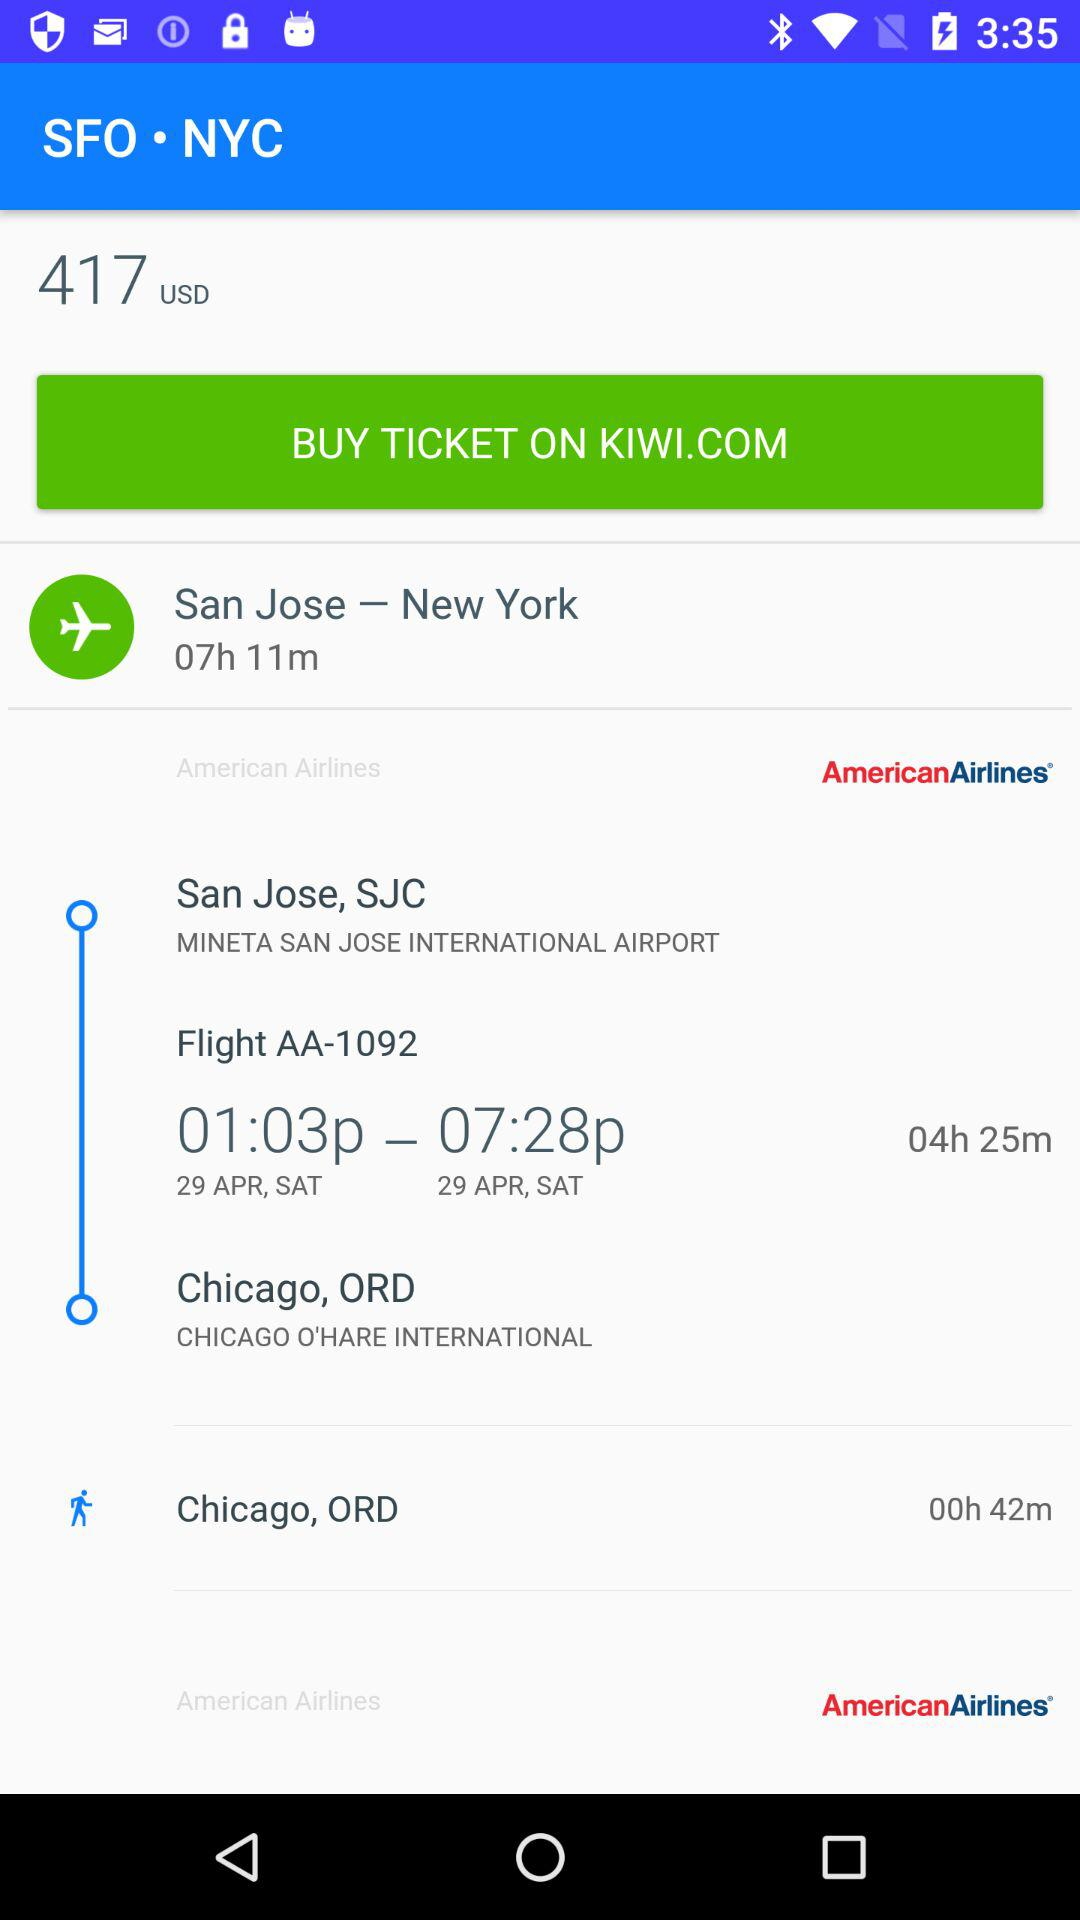What is the ticket price? The ticket price is 417 USD. 